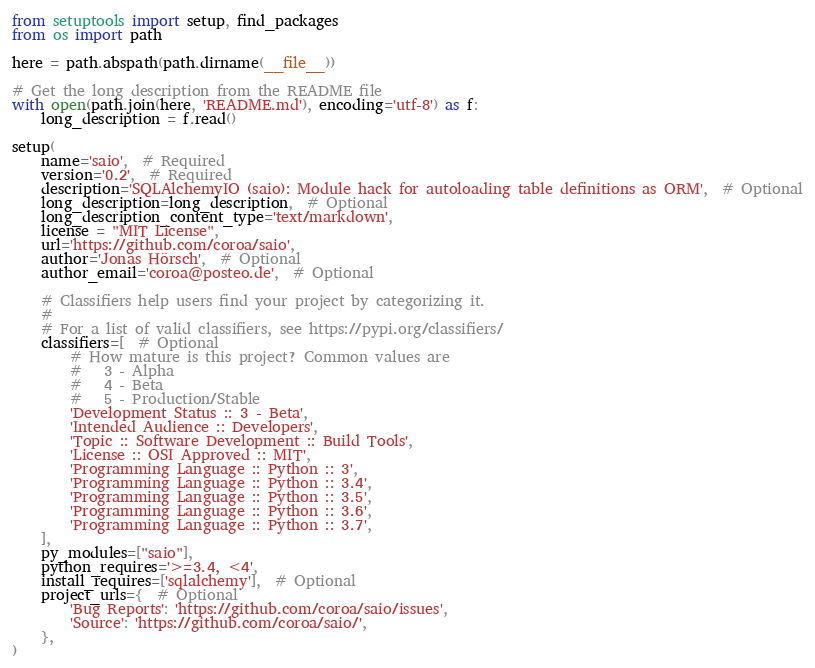<code> <loc_0><loc_0><loc_500><loc_500><_Python_>from setuptools import setup, find_packages
from os import path

here = path.abspath(path.dirname(__file__))

# Get the long description from the README file
with open(path.join(here, 'README.md'), encoding='utf-8') as f:
    long_description = f.read()

setup(
    name='saio',  # Required
    version='0.2',  # Required
    description='SQLAlchemyIO (saio): Module hack for autoloading table definitions as ORM',  # Optional
    long_description=long_description,  # Optional
    long_description_content_type='text/markdown',
    license = "MIT License",
    url='https://github.com/coroa/saio',
    author='Jonas Hörsch',  # Optional
    author_email='coroa@posteo.de',  # Optional

    # Classifiers help users find your project by categorizing it.
    #
    # For a list of valid classifiers, see https://pypi.org/classifiers/
    classifiers=[  # Optional
        # How mature is this project? Common values are
        #   3 - Alpha
        #   4 - Beta
        #   5 - Production/Stable
        'Development Status :: 3 - Beta',
        'Intended Audience :: Developers',
        'Topic :: Software Development :: Build Tools',
        'License :: OSI Approved :: MIT',
        'Programming Language :: Python :: 3',
        'Programming Language :: Python :: 3.4',
        'Programming Language :: Python :: 3.5',
        'Programming Language :: Python :: 3.6',
        'Programming Language :: Python :: 3.7',
    ],
    py_modules=["saio"],
    python_requires='>=3.4, <4',
    install_requires=['sqlalchemy'],  # Optional
    project_urls={  # Optional
        'Bug Reports': 'https://github.com/coroa/saio/issues',
        'Source': 'https://github.com/coroa/saio/',
    },
)
</code> 